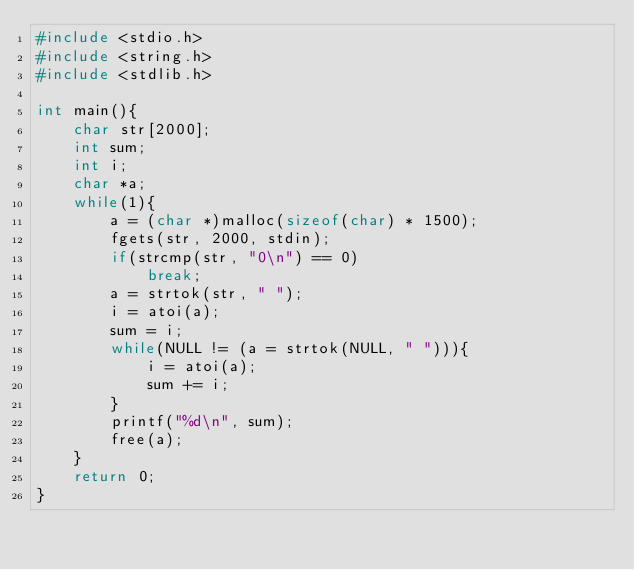<code> <loc_0><loc_0><loc_500><loc_500><_C_>#include <stdio.h>
#include <string.h>
#include <stdlib.h>

int main(){
	char str[2000];
	int sum;
	int i;
	char *a;
	while(1){
		a = (char *)malloc(sizeof(char) * 1500);
		fgets(str, 2000, stdin);
		if(strcmp(str, "0\n") == 0)
			break;
		a = strtok(str, " ");
		i = atoi(a);
		sum = i;
		while(NULL != (a = strtok(NULL, " "))){
			i = atoi(a);
			sum += i;
		}
		printf("%d\n", sum);
		free(a);
	}
	return 0;
}</code> 